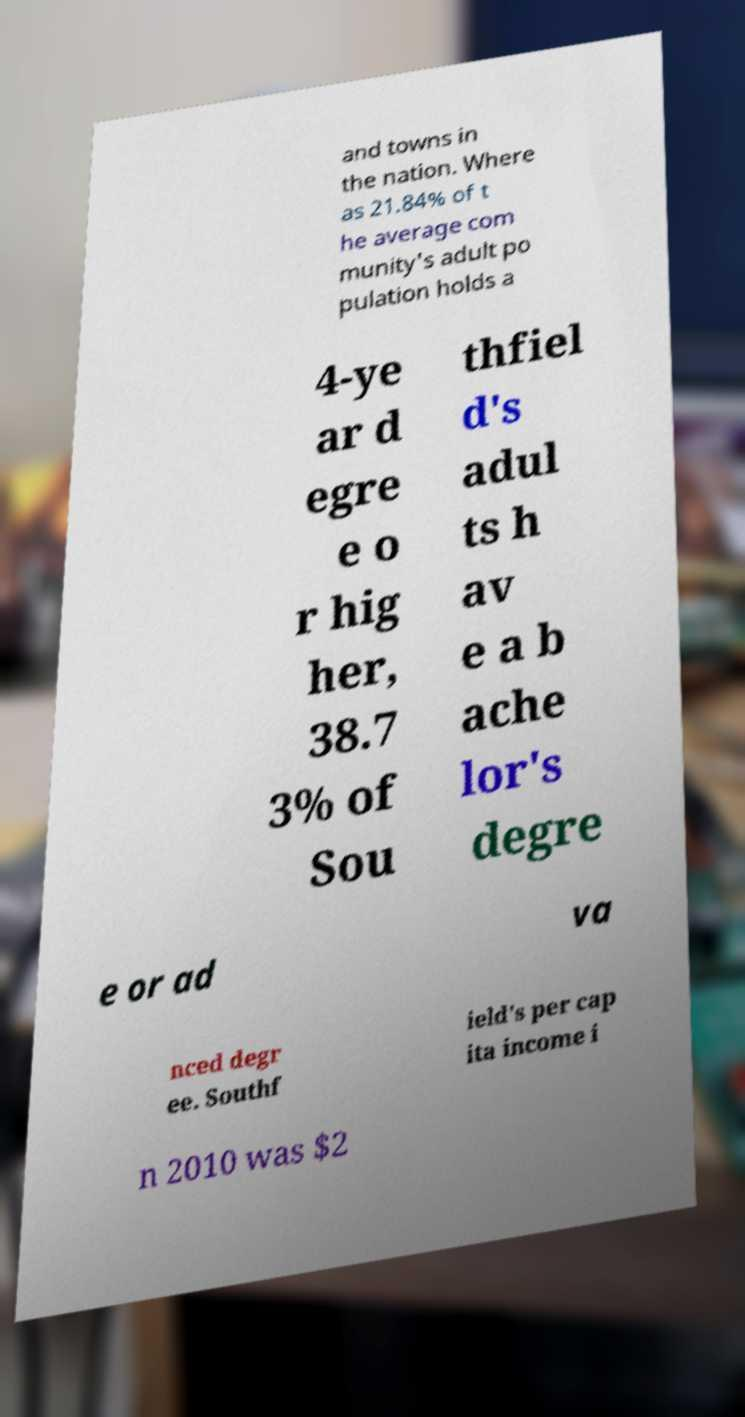There's text embedded in this image that I need extracted. Can you transcribe it verbatim? and towns in the nation. Where as 21.84% of t he average com munity's adult po pulation holds a 4-ye ar d egre e o r hig her, 38.7 3% of Sou thfiel d's adul ts h av e a b ache lor's degre e or ad va nced degr ee. Southf ield's per cap ita income i n 2010 was $2 